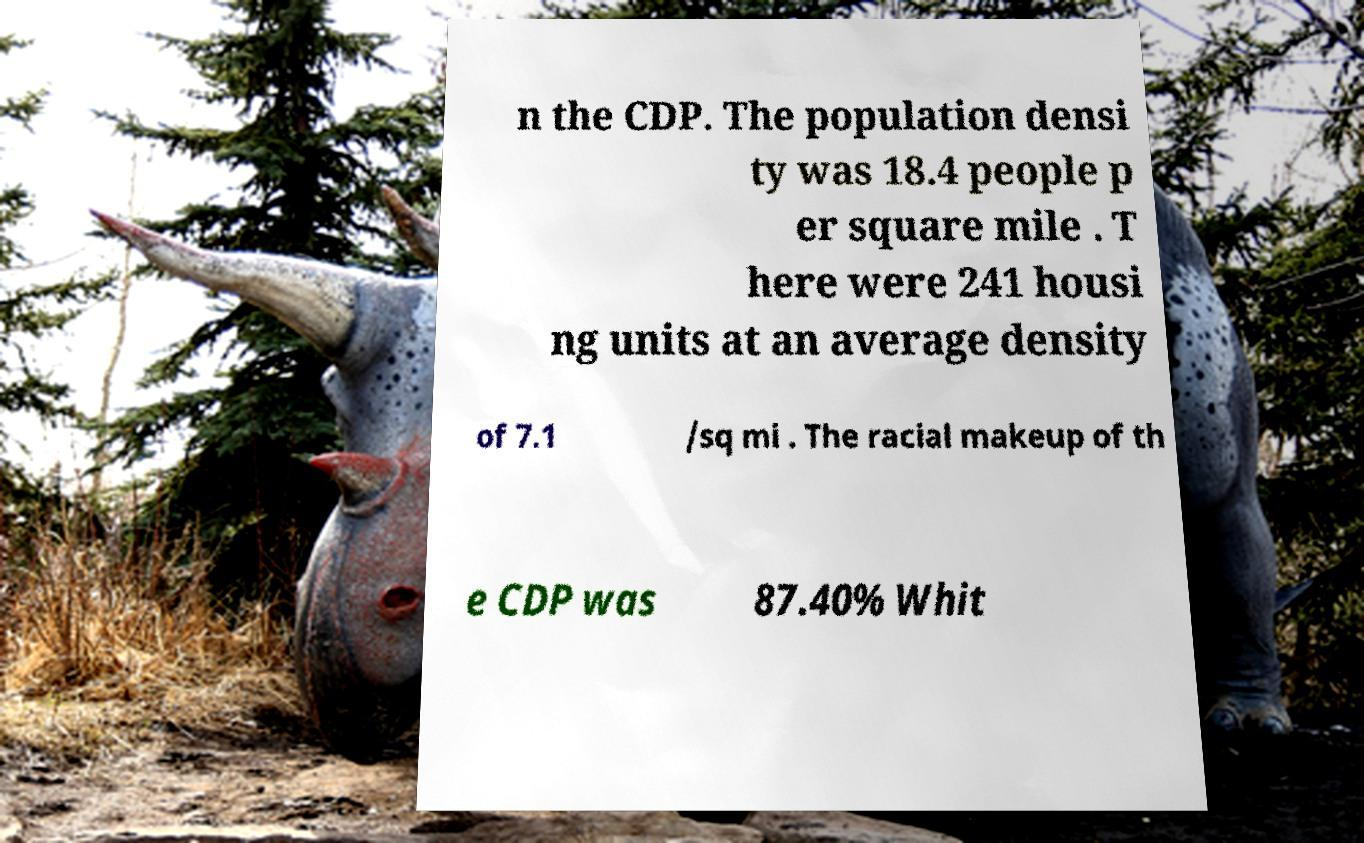I need the written content from this picture converted into text. Can you do that? n the CDP. The population densi ty was 18.4 people p er square mile . T here were 241 housi ng units at an average density of 7.1 /sq mi . The racial makeup of th e CDP was 87.40% Whit 